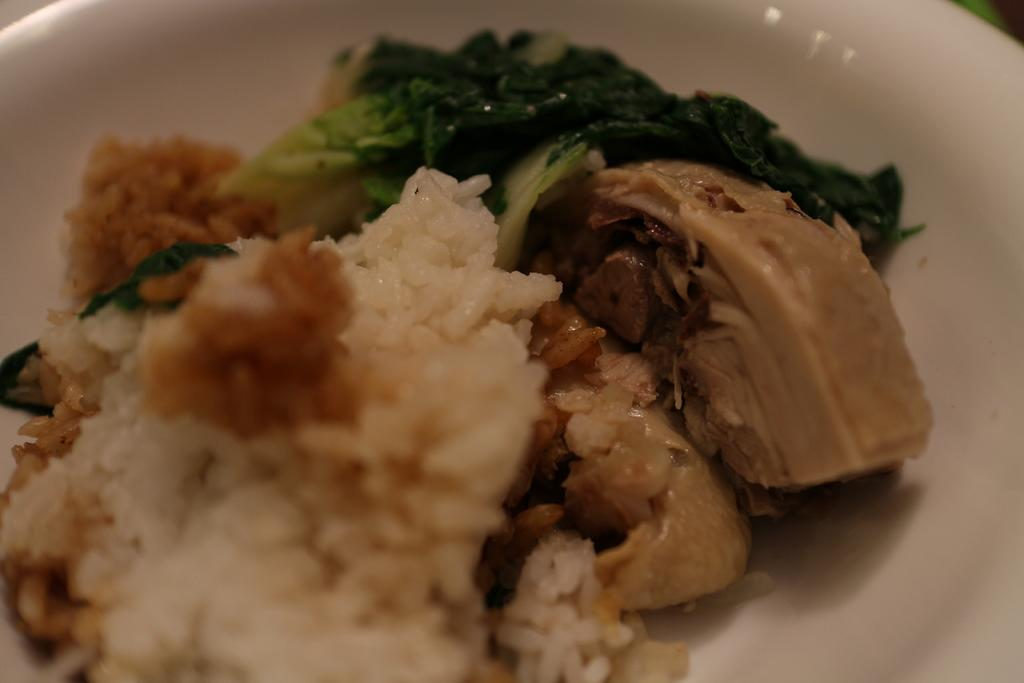What type of food is on the plate in the image? There is rice, meat, and leafy vegetables on a plate in the image. Can you describe the different components of the meal? The meal consists of rice, meat, and leafy vegetables. What type of gun is being used to cook the vegetables in the image? There is no gun present in the image; the vegetables are not being cooked. 